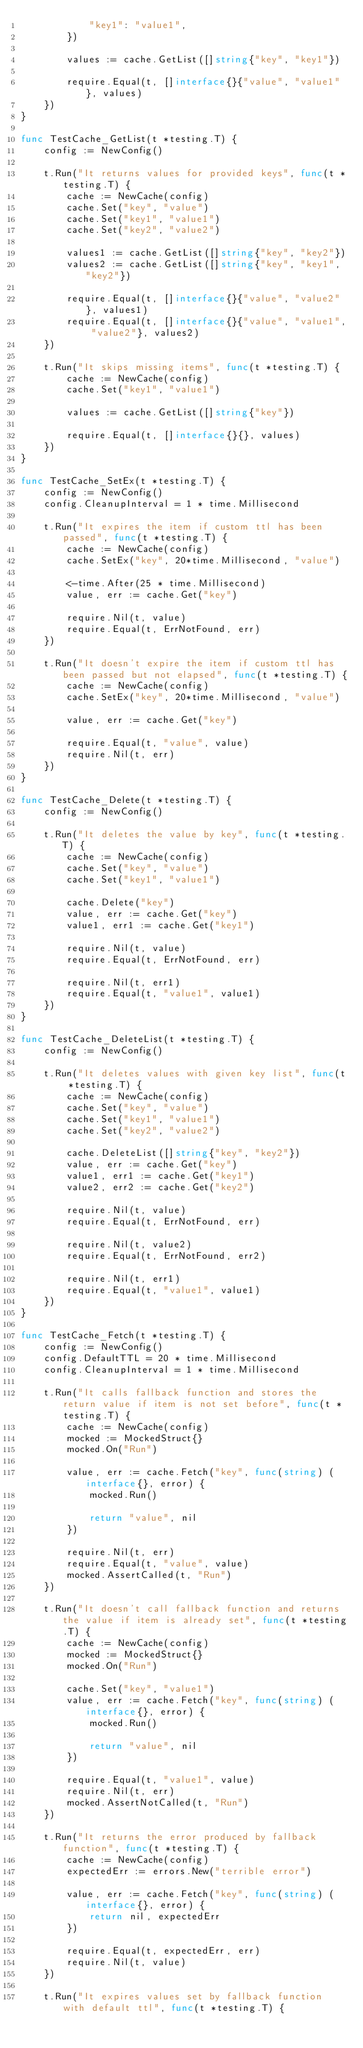Convert code to text. <code><loc_0><loc_0><loc_500><loc_500><_Go_>			"key1": "value1",
		})

		values := cache.GetList([]string{"key", "key1"})

		require.Equal(t, []interface{}{"value", "value1"}, values)
	})
}

func TestCache_GetList(t *testing.T) {
	config := NewConfig()

	t.Run("It returns values for provided keys", func(t *testing.T) {
		cache := NewCache(config)
		cache.Set("key", "value")
		cache.Set("key1", "value1")
		cache.Set("key2", "value2")

		values1 := cache.GetList([]string{"key", "key2"})
		values2 := cache.GetList([]string{"key", "key1", "key2"})

		require.Equal(t, []interface{}{"value", "value2"}, values1)
		require.Equal(t, []interface{}{"value", "value1", "value2"}, values2)
	})

	t.Run("It skips missing items", func(t *testing.T) {
		cache := NewCache(config)
		cache.Set("key1", "value1")

		values := cache.GetList([]string{"key"})

		require.Equal(t, []interface{}{}, values)
	})
}

func TestCache_SetEx(t *testing.T) {
	config := NewConfig()
	config.CleanupInterval = 1 * time.Millisecond

	t.Run("It expires the item if custom ttl has been passed", func(t *testing.T) {
		cache := NewCache(config)
		cache.SetEx("key", 20*time.Millisecond, "value")

		<-time.After(25 * time.Millisecond)
		value, err := cache.Get("key")

		require.Nil(t, value)
		require.Equal(t, ErrNotFound, err)
	})

	t.Run("It doesn't expire the item if custom ttl has been passed but not elapsed", func(t *testing.T) {
		cache := NewCache(config)
		cache.SetEx("key", 20*time.Millisecond, "value")

		value, err := cache.Get("key")

		require.Equal(t, "value", value)
		require.Nil(t, err)
	})
}

func TestCache_Delete(t *testing.T) {
	config := NewConfig()

	t.Run("It deletes the value by key", func(t *testing.T) {
		cache := NewCache(config)
		cache.Set("key", "value")
		cache.Set("key1", "value1")

		cache.Delete("key")
		value, err := cache.Get("key")
		value1, err1 := cache.Get("key1")

		require.Nil(t, value)
		require.Equal(t, ErrNotFound, err)

		require.Nil(t, err1)
		require.Equal(t, "value1", value1)
	})
}

func TestCache_DeleteList(t *testing.T) {
	config := NewConfig()

	t.Run("It deletes values with given key list", func(t *testing.T) {
		cache := NewCache(config)
		cache.Set("key", "value")
		cache.Set("key1", "value1")
		cache.Set("key2", "value2")

		cache.DeleteList([]string{"key", "key2"})
		value, err := cache.Get("key")
		value1, err1 := cache.Get("key1")
		value2, err2 := cache.Get("key2")

		require.Nil(t, value)
		require.Equal(t, ErrNotFound, err)

		require.Nil(t, value2)
		require.Equal(t, ErrNotFound, err2)

		require.Nil(t, err1)
		require.Equal(t, "value1", value1)
	})
}

func TestCache_Fetch(t *testing.T) {
	config := NewConfig()
	config.DefaultTTL = 20 * time.Millisecond
	config.CleanupInterval = 1 * time.Millisecond

	t.Run("It calls fallback function and stores the return value if item is not set before", func(t *testing.T) {
		cache := NewCache(config)
		mocked := MockedStruct{}
		mocked.On("Run")

		value, err := cache.Fetch("key", func(string) (interface{}, error) {
			mocked.Run()

			return "value", nil
		})

		require.Nil(t, err)
		require.Equal(t, "value", value)
		mocked.AssertCalled(t, "Run")
	})

	t.Run("It doesn't call fallback function and returns the value if item is already set", func(t *testing.T) {
		cache := NewCache(config)
		mocked := MockedStruct{}
		mocked.On("Run")

		cache.Set("key", "value1")
		value, err := cache.Fetch("key", func(string) (interface{}, error) {
			mocked.Run()

			return "value", nil
		})

		require.Equal(t, "value1", value)
		require.Nil(t, err)
		mocked.AssertNotCalled(t, "Run")
	})

	t.Run("It returns the error produced by fallback function", func(t *testing.T) {
		cache := NewCache(config)
		expectedErr := errors.New("terrible error")

		value, err := cache.Fetch("key", func(string) (interface{}, error) {
			return nil, expectedErr
		})

		require.Equal(t, expectedErr, err)
		require.Nil(t, value)
	})

	t.Run("It expires values set by fallback function with default ttl", func(t *testing.T) {</code> 